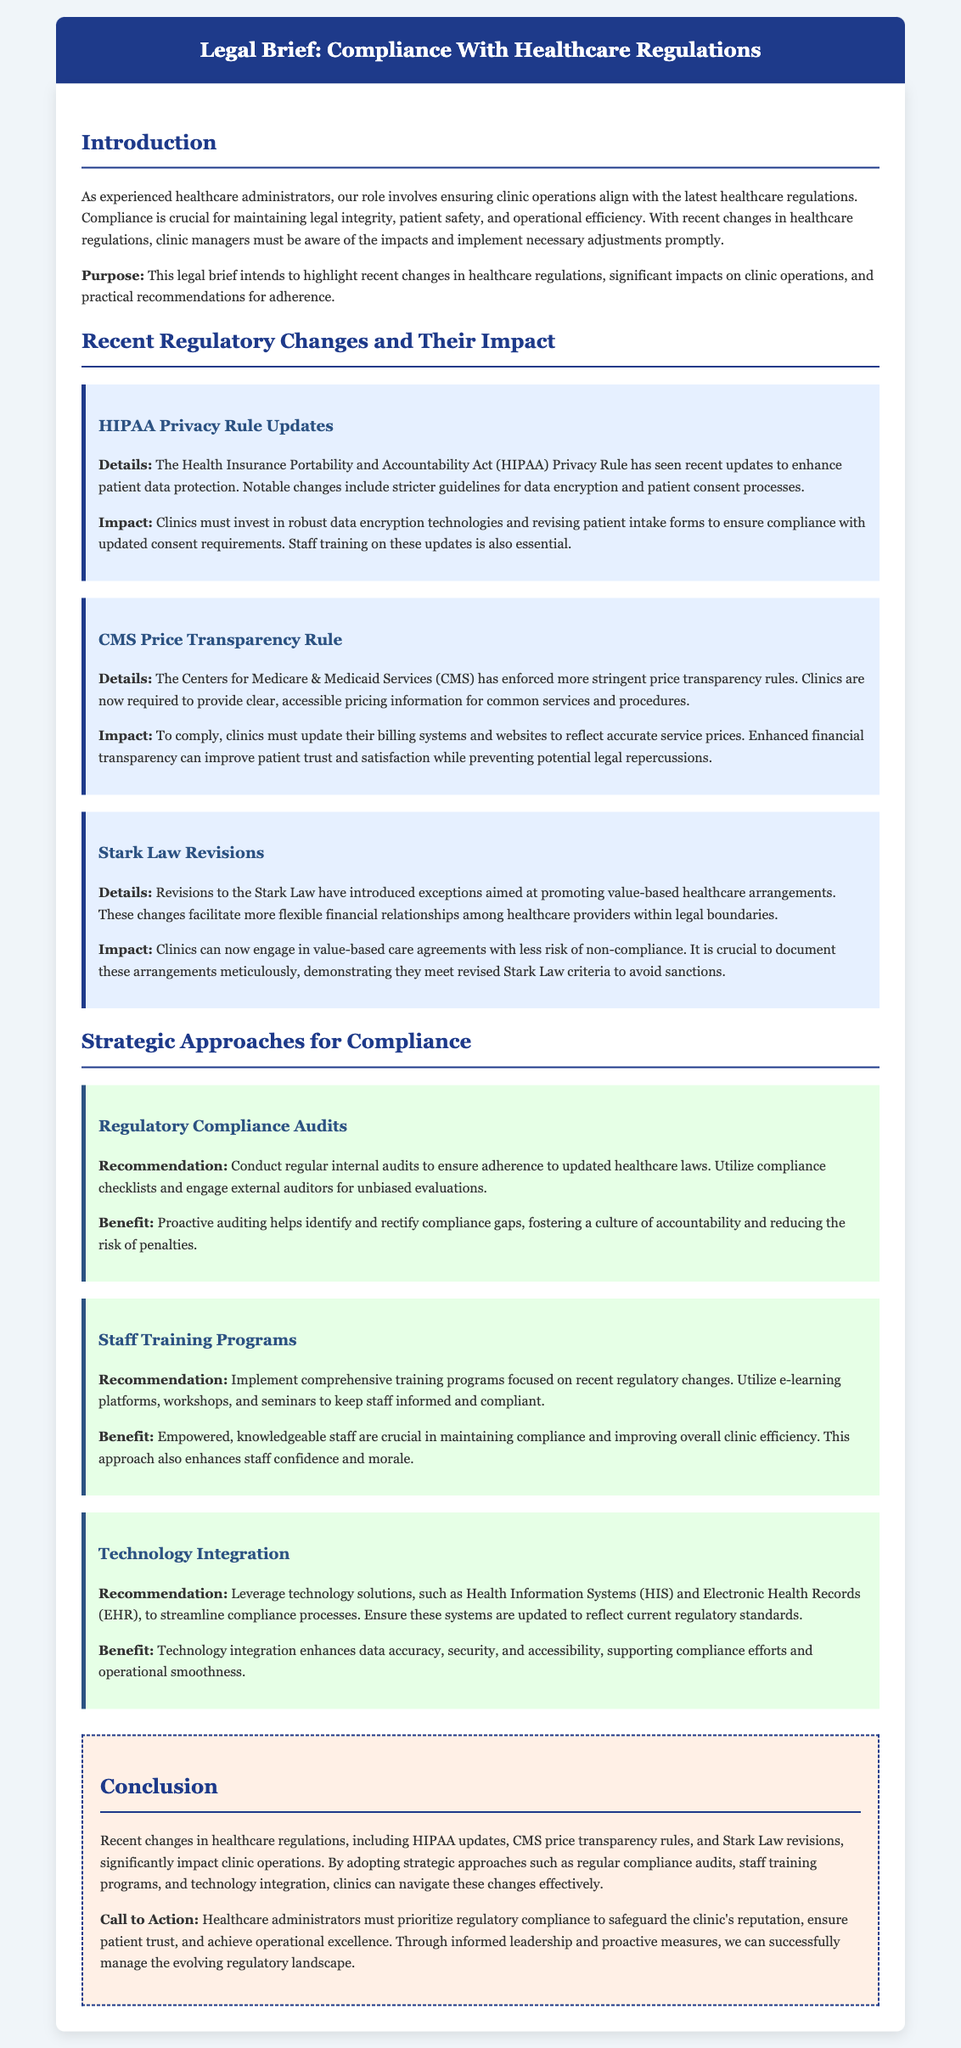what are the recent updates to the HIPAA Privacy Rule? The document indicates that recent updates include stricter guidelines for data encryption and patient consent processes.
Answer: stricter guidelines for data encryption and patient consent processes what is one impact of the CMS Price Transparency Rule? The document states that clinics must update their billing systems and websites to reflect accurate service prices.
Answer: update billing systems and websites what type of audits does the document recommend? The document suggests conducting regular internal audits to ensure adherence to updated healthcare laws.
Answer: regular internal audits what is a key benefit of implementing staff training programs? According to the document, empowered, knowledgeable staff are crucial in maintaining compliance and improving overall clinic efficiency.
Answer: maintaining compliance and improving overall clinic efficiency how are value-based healthcare arrangements affected by Stark Law revisions? The document notes that revisions facilitate more flexible financial relationships among healthcare providers within legal boundaries.
Answer: more flexible financial relationships what is the purpose of the legal brief? The document explains that the purpose is to highlight recent changes in healthcare regulations and recommend practical adherence strategies.
Answer: highlight recent changes and recommend practical adherence strategies how should clinics approach technology integration for compliance? The document recommends leveraging technology solutions to streamline compliance processes and ensure they reflect current regulatory standards.
Answer: leverage technology solutions what should clinics prioritize according to the conclusion of the document? The conclusion calls for healthcare administrators to prioritize regulatory compliance to safeguard the clinic's reputation and ensure patient trust.
Answer: prioritize regulatory compliance 